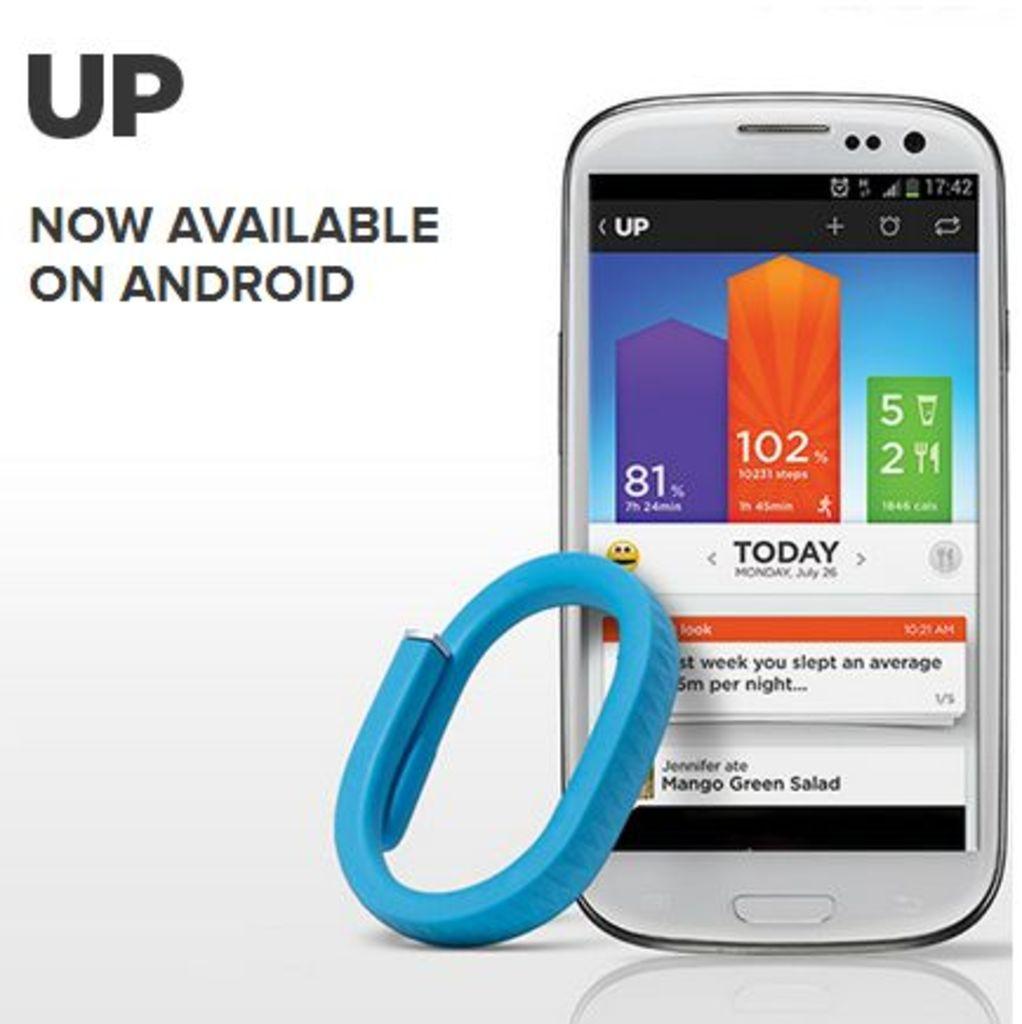What app is this an ad for?
Provide a short and direct response. Up. What is the app now availale on?
Make the answer very short. Android. 